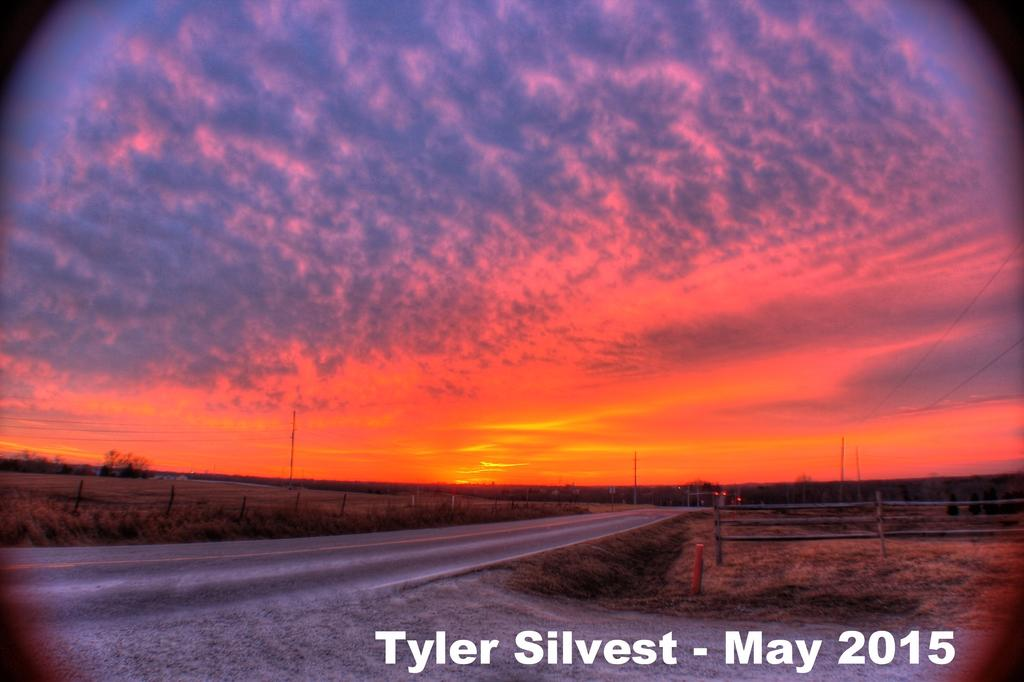What is located at the bottom of the image? There is a road, railing, grass, poles, and trees at the bottom of the image. What type of barrier is present at the bottom of the image? The railing serves as a barrier at the bottom of the image. What type of vegetation is present at the bottom of the image? Grass and trees are present at the bottom of the image. What is the condition of the sky in the image? The sky is cloudy in the image. Is there any text or writing on the image? Yes, there is something written on the image. What type of brush can be seen cleaning the road in the image? There is no brush present in the image, and the road does not appear to be cleaned in the image. What type of crime is being committed in the image? There is no crime or criminal activity depicted in the image. 